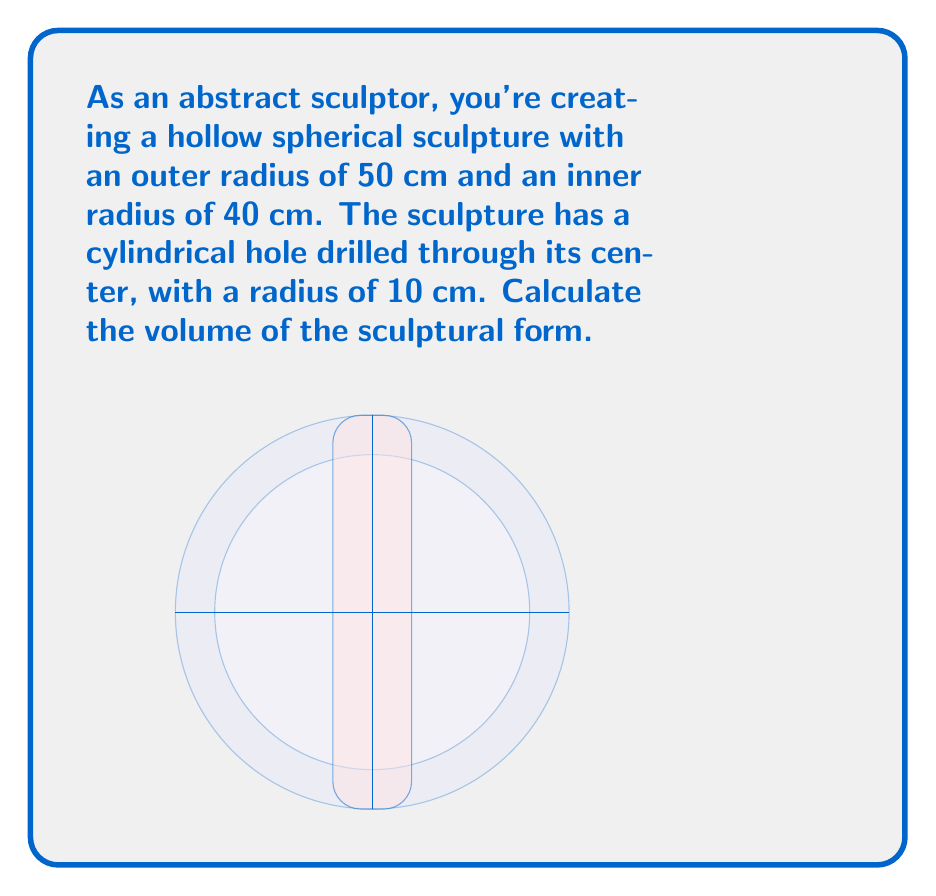Provide a solution to this math problem. Let's approach this problem step by step:

1) First, we need to calculate the volume of a solid sphere with radius 50 cm:
   $$V_{outer} = \frac{4}{3}\pi r^3 = \frac{4}{3}\pi (50)^3 = \frac{500000\pi}{3} \text{ cm}^3$$

2) Next, calculate the volume of the inner sphere with radius 40 cm:
   $$V_{inner} = \frac{4}{3}\pi r^3 = \frac{4}{3}\pi (40)^3 = \frac{256000\pi}{3} \text{ cm}^3$$

3) The volume of the hollow sphere is the difference between these:
   $$V_{hollow} = V_{outer} - V_{inner} = \frac{500000\pi}{3} - \frac{256000\pi}{3} = \frac{244000\pi}{3} \text{ cm}^3$$

4) Now, we need to subtract the volume of the cylindrical hole:
   The volume of a cylinder is $V = \pi r^2 h$
   Here, $r = 10$ cm and $h = 100$ cm (diameter of the sphere)
   $$V_{cylinder} = \pi (10)^2 (100) = 10000\pi \text{ cm}^3$$

5) Finally, the volume of the sculptural form is:
   $$V_{sculpture} = V_{hollow} - V_{cylinder} = \frac{244000\pi}{3} - 10000\pi = \frac{214000\pi}{3} \text{ cm}^3$$
Answer: $\frac{214000\pi}{3} \text{ cm}^3$ 